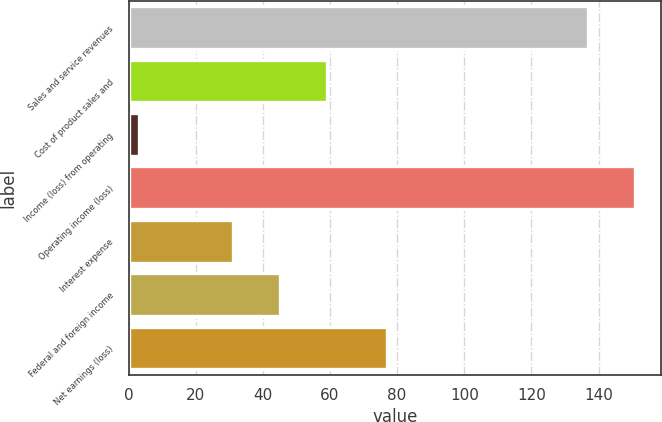<chart> <loc_0><loc_0><loc_500><loc_500><bar_chart><fcel>Sales and service revenues<fcel>Cost of product sales and<fcel>Income (loss) from operating<fcel>Operating income (loss)<fcel>Interest expense<fcel>Federal and foreign income<fcel>Net earnings (loss)<nl><fcel>137<fcel>59<fcel>3<fcel>151<fcel>31<fcel>45<fcel>77<nl></chart> 